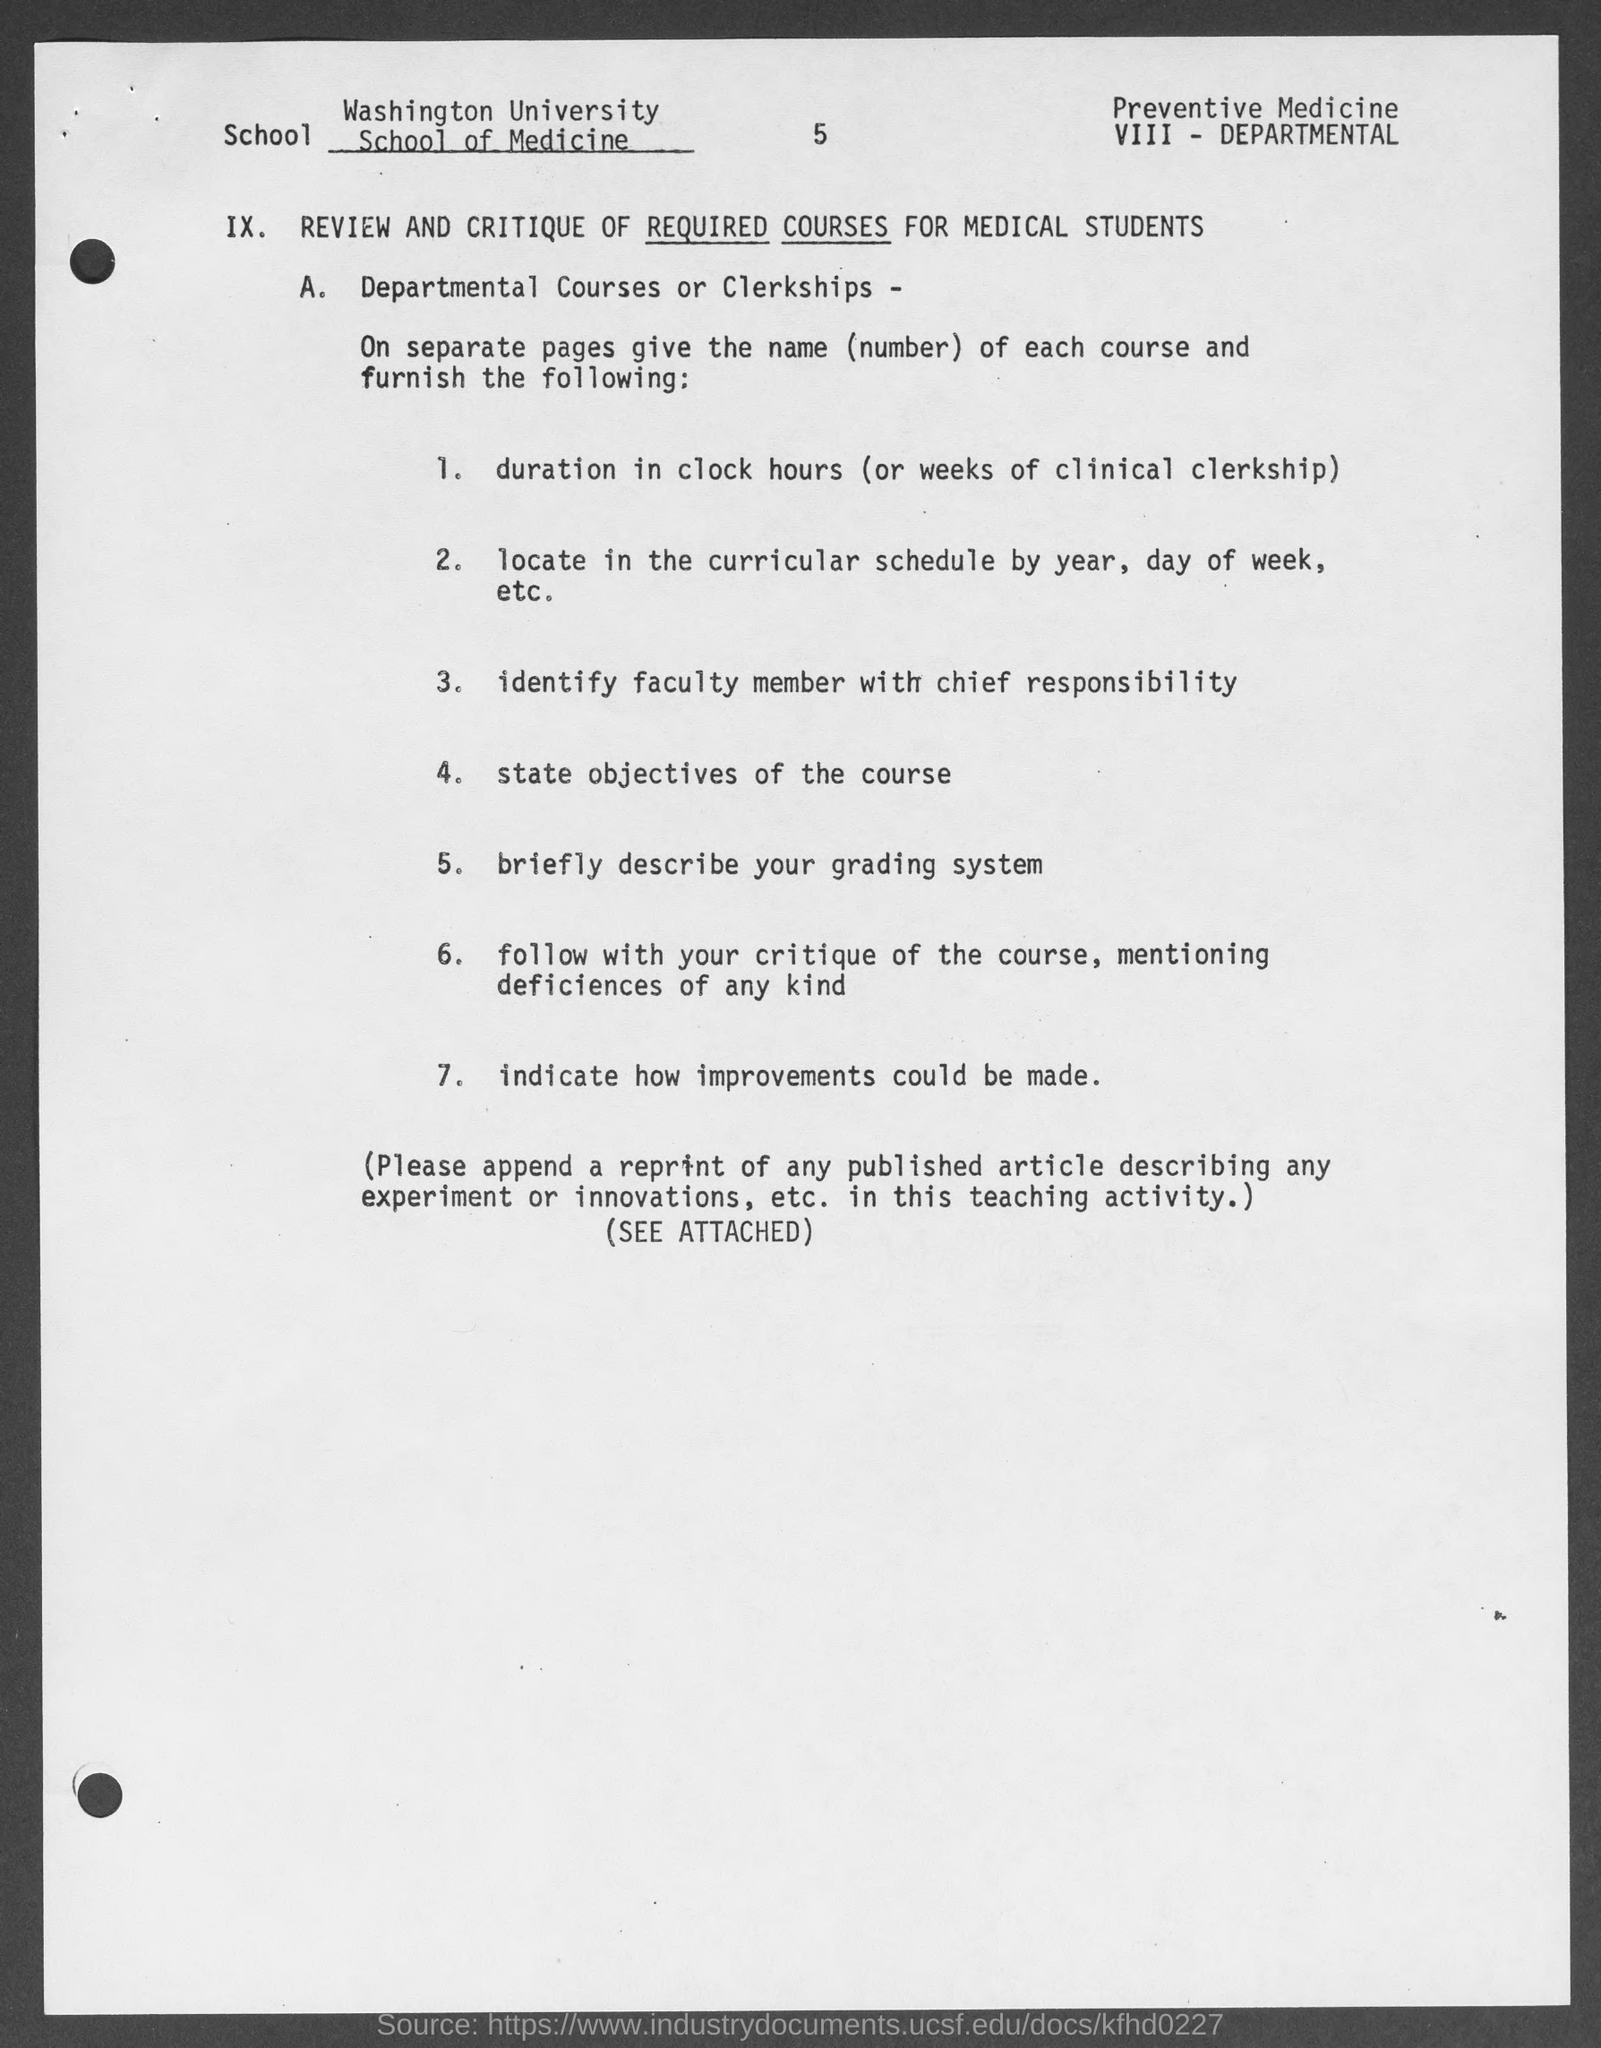Which school is mentioned in the document?
Provide a short and direct response. WASHINGTON UNIVERSITY SCHOOL OF MEDICINE. What is the page no mentioned in this document?
Your answer should be compact. 5. 